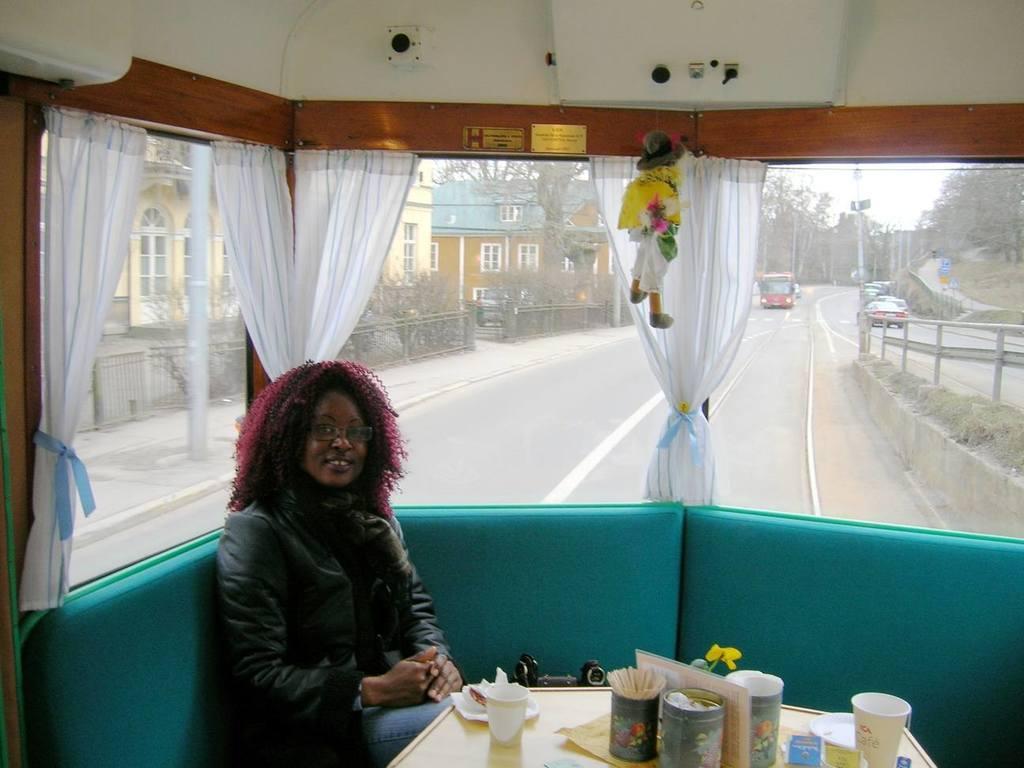Can you describe this image briefly? There is a lady sitting on the left side of the image and a table at the bottom side, on which there is a cup, it seems like a flower and other items. There is a toy, curtains, and glass windows behind her, there are vehicles, houses, trees, pole and sky in the background area. 